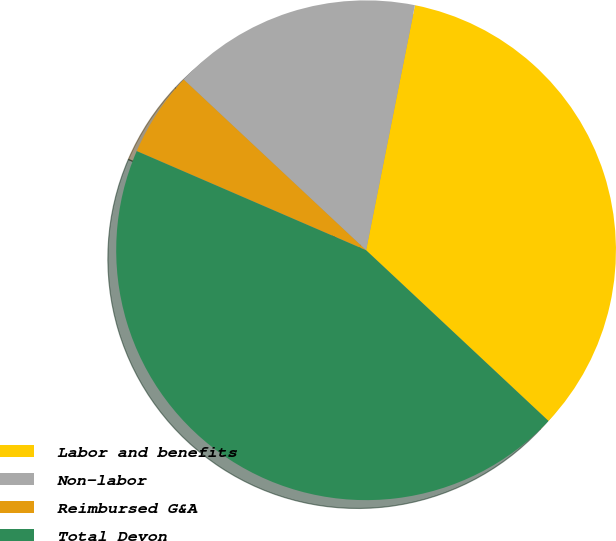Convert chart to OTSL. <chart><loc_0><loc_0><loc_500><loc_500><pie_chart><fcel>Labor and benefits<fcel>Non-labor<fcel>Reimbursed G&A<fcel>Total Devon<nl><fcel>33.84%<fcel>16.16%<fcel>5.48%<fcel>44.52%<nl></chart> 